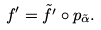<formula> <loc_0><loc_0><loc_500><loc_500>f ^ { \prime } = \tilde { f ^ { \prime } } \circ p _ { \tilde { \alpha } } .</formula> 